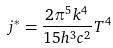<formula> <loc_0><loc_0><loc_500><loc_500>j ^ { * } = \frac { 2 \pi ^ { 5 } k ^ { 4 } } { 1 5 h ^ { 3 } c ^ { 2 } } T ^ { 4 }</formula> 